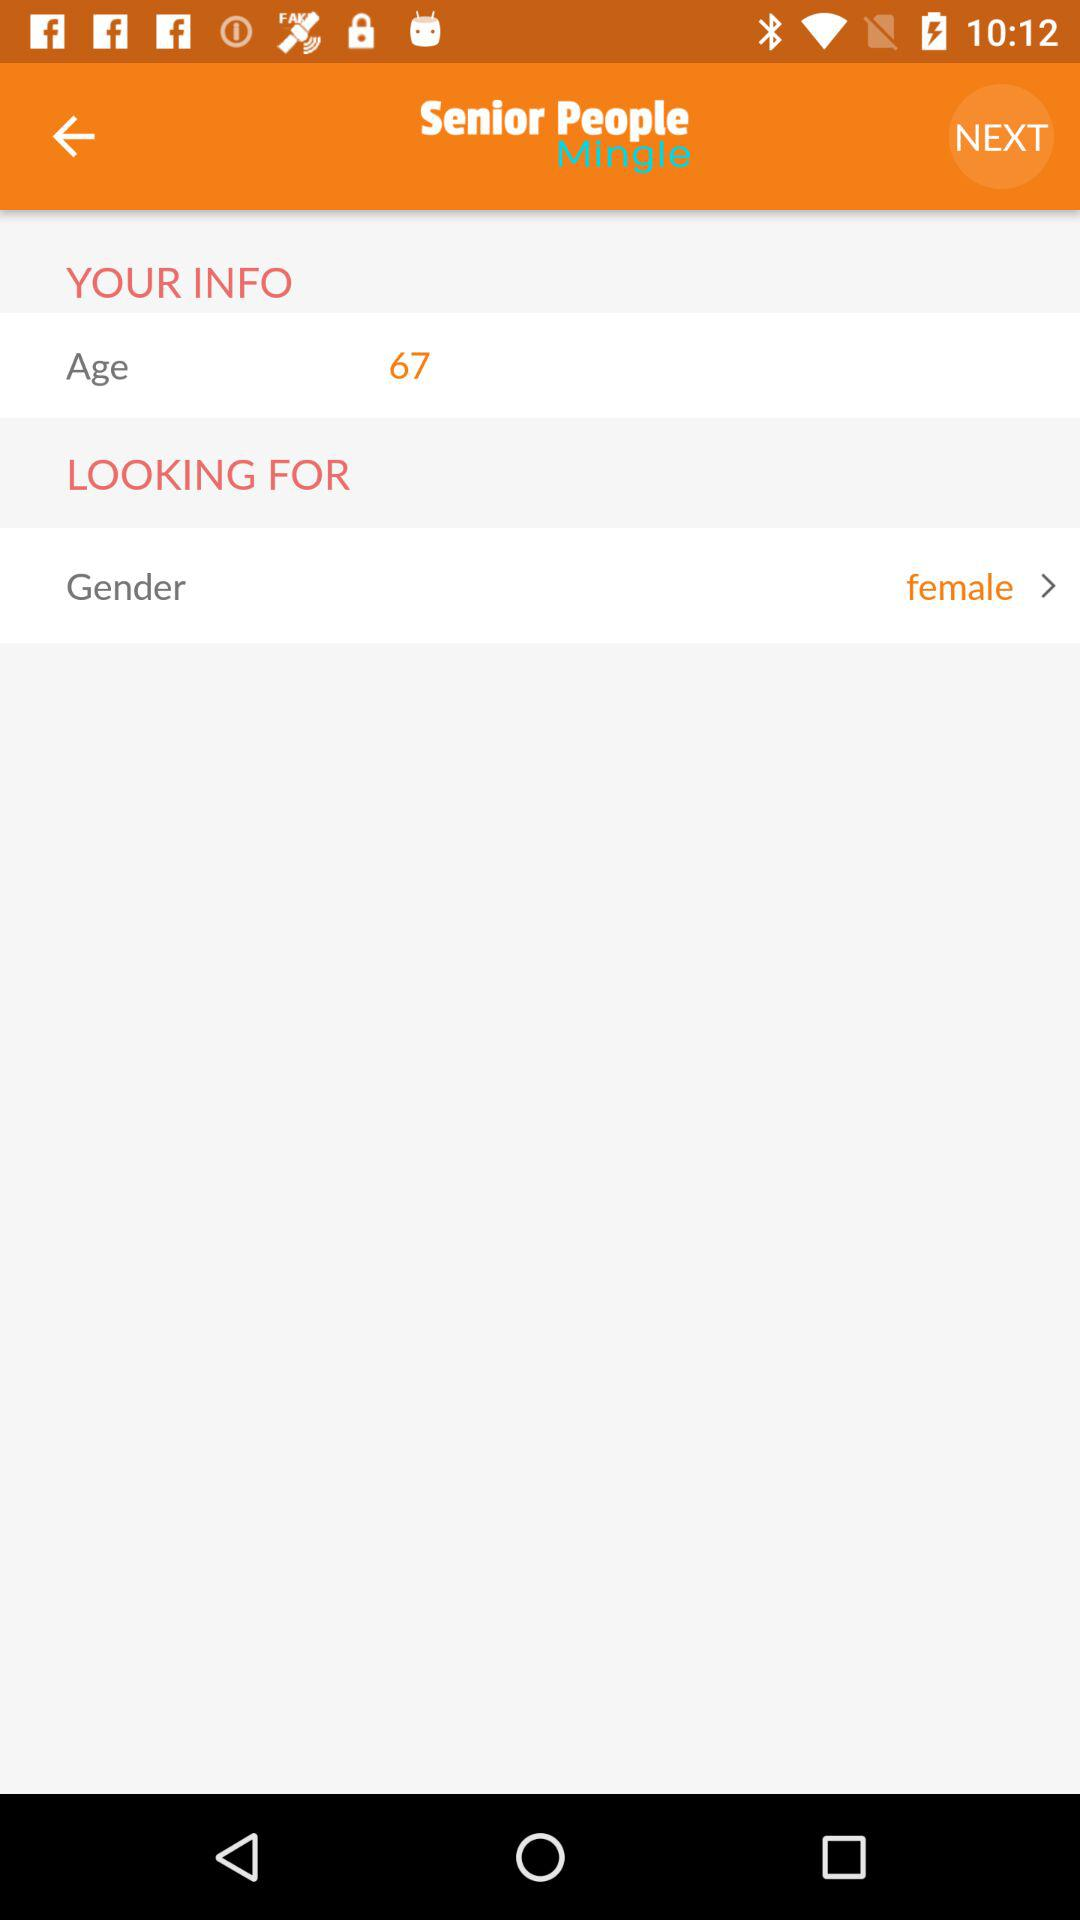Which gender is selected? The selected gender is female. 